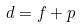Convert formula to latex. <formula><loc_0><loc_0><loc_500><loc_500>d = f + p</formula> 